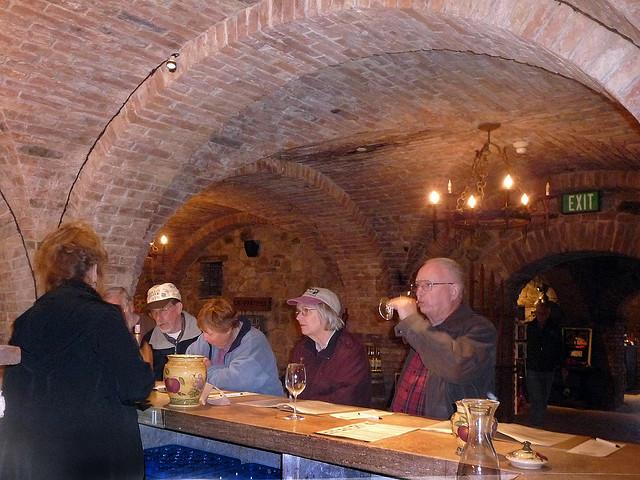Are they drinking wine?
Keep it brief. Yes. What is the ceiling made of?
Be succinct. Brick. How many customers are sitting at the bar?
Short answer required. 4. 